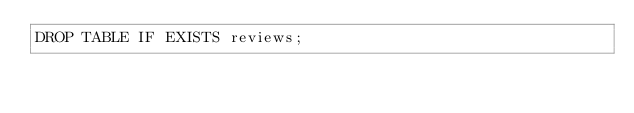Convert code to text. <code><loc_0><loc_0><loc_500><loc_500><_SQL_>DROP TABLE IF EXISTS reviews;</code> 